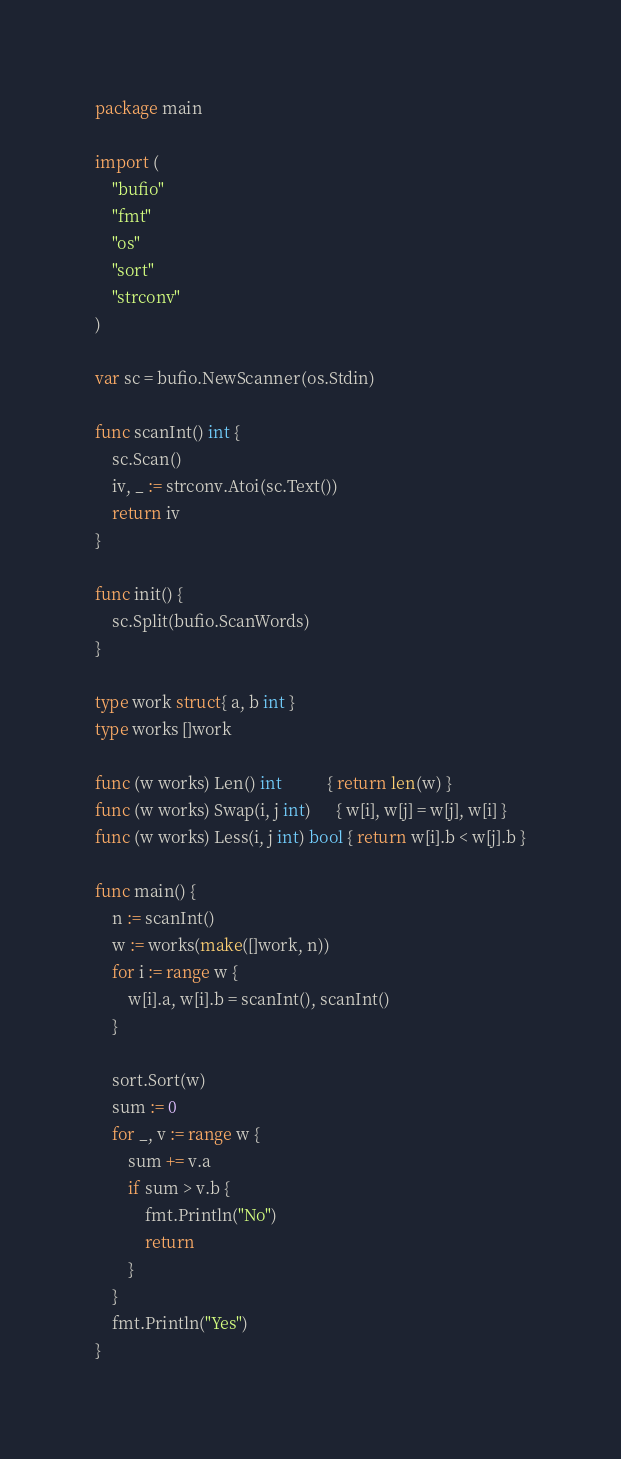<code> <loc_0><loc_0><loc_500><loc_500><_Go_>package main

import (
	"bufio"
	"fmt"
	"os"
	"sort"
	"strconv"
)

var sc = bufio.NewScanner(os.Stdin)

func scanInt() int {
	sc.Scan()
	iv, _ := strconv.Atoi(sc.Text())
	return iv
}

func init() {
	sc.Split(bufio.ScanWords)
}

type work struct{ a, b int }
type works []work

func (w works) Len() int           { return len(w) }
func (w works) Swap(i, j int)      { w[i], w[j] = w[j], w[i] }
func (w works) Less(i, j int) bool { return w[i].b < w[j].b }

func main() {
	n := scanInt()
	w := works(make([]work, n))
	for i := range w {
		w[i].a, w[i].b = scanInt(), scanInt()
	}

	sort.Sort(w)
	sum := 0
	for _, v := range w {
		sum += v.a
		if sum > v.b {
			fmt.Println("No")
			return
		}
	}
	fmt.Println("Yes")
}
</code> 